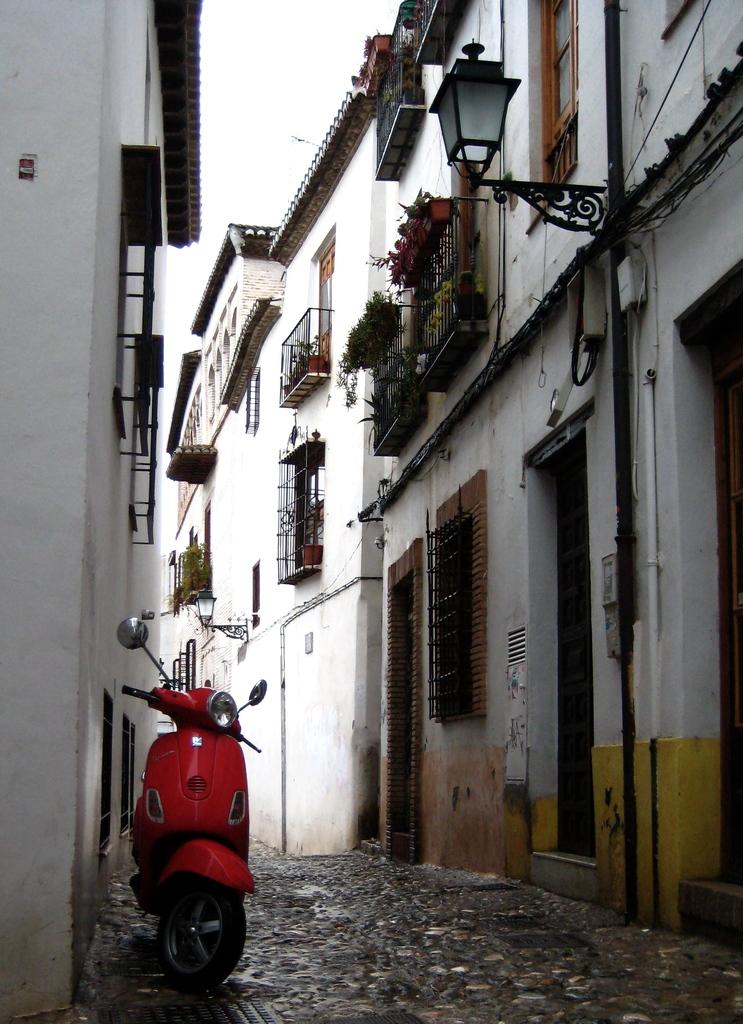What type of vehicle is in the image? There is a red color bike in the image. Where is the bike located in relation to the path? The bike is parked on the left side of the path. What can be seen on both sides of the path? There are buildings on either side of the path. What is visible in the background of the image? The sky is visible in the background of the image. What type of cheese is being served at the daughter's birthday party in the image? There is no mention of a daughter or a birthday party in the image, nor is there any cheese present. 